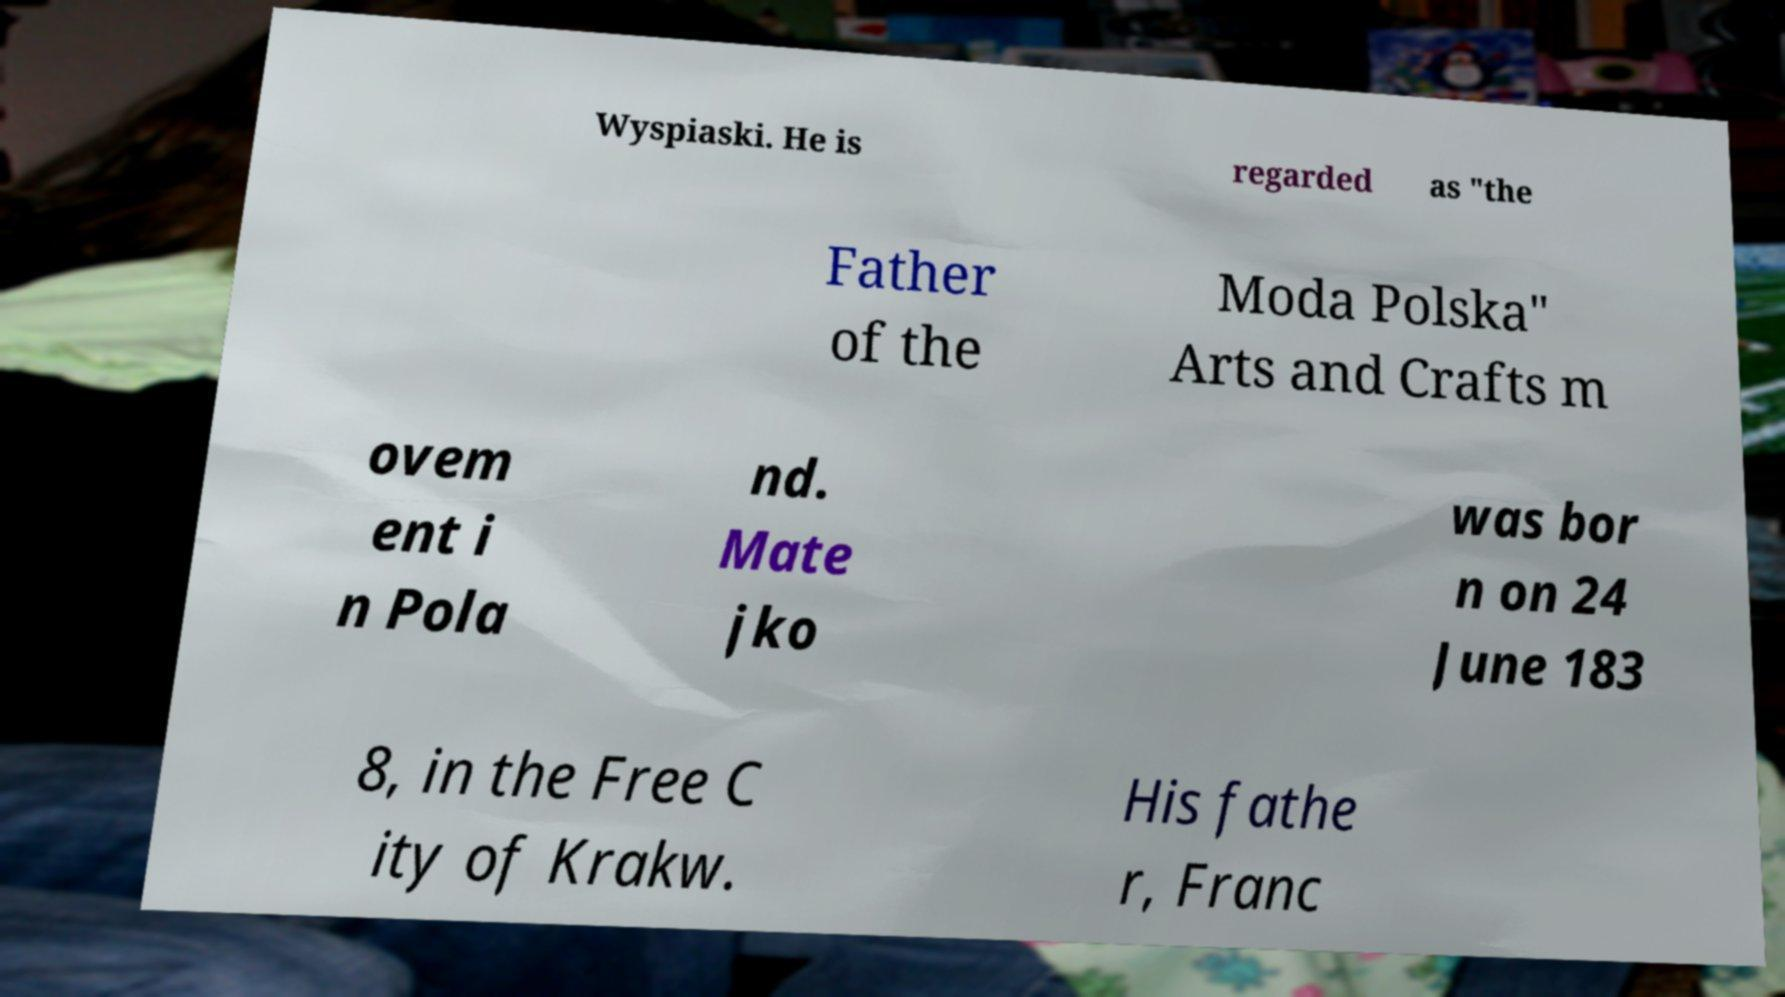For documentation purposes, I need the text within this image transcribed. Could you provide that? Wyspiaski. He is regarded as "the Father of the Moda Polska" Arts and Crafts m ovem ent i n Pola nd. Mate jko was bor n on 24 June 183 8, in the Free C ity of Krakw. His fathe r, Franc 